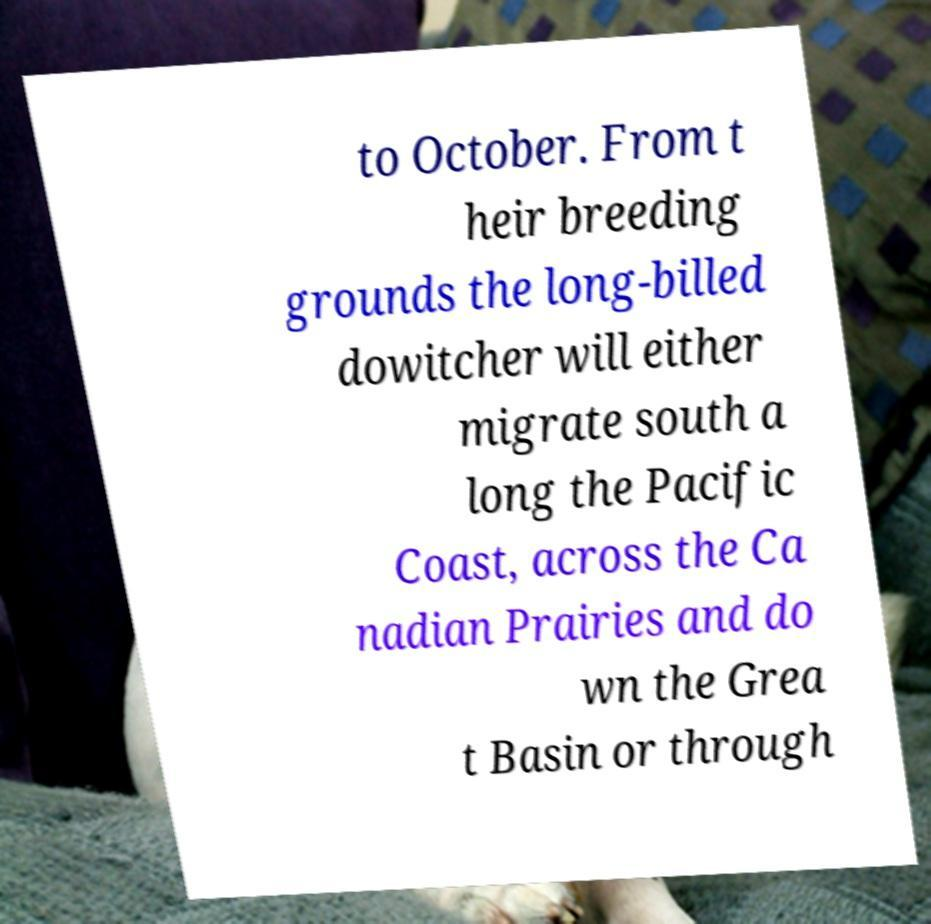There's text embedded in this image that I need extracted. Can you transcribe it verbatim? to October. From t heir breeding grounds the long-billed dowitcher will either migrate south a long the Pacific Coast, across the Ca nadian Prairies and do wn the Grea t Basin or through 